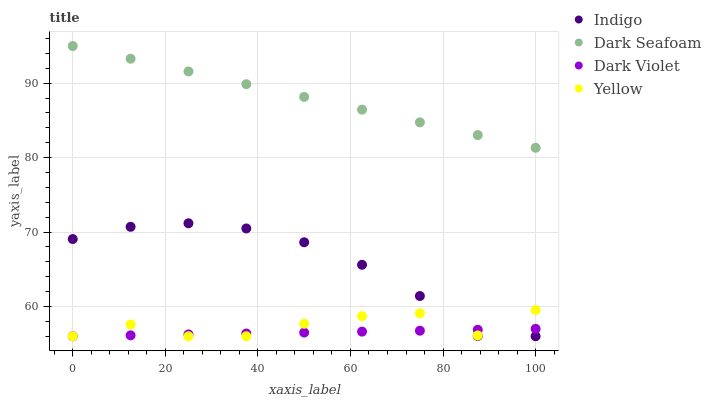Does Dark Violet have the minimum area under the curve?
Answer yes or no. Yes. Does Dark Seafoam have the maximum area under the curve?
Answer yes or no. Yes. Does Indigo have the minimum area under the curve?
Answer yes or no. No. Does Indigo have the maximum area under the curve?
Answer yes or no. No. Is Dark Seafoam the smoothest?
Answer yes or no. Yes. Is Yellow the roughest?
Answer yes or no. Yes. Is Indigo the smoothest?
Answer yes or no. No. Is Indigo the roughest?
Answer yes or no. No. Does Indigo have the lowest value?
Answer yes or no. Yes. Does Dark Seafoam have the highest value?
Answer yes or no. Yes. Does Indigo have the highest value?
Answer yes or no. No. Is Yellow less than Dark Seafoam?
Answer yes or no. Yes. Is Dark Seafoam greater than Dark Violet?
Answer yes or no. Yes. Does Yellow intersect Indigo?
Answer yes or no. Yes. Is Yellow less than Indigo?
Answer yes or no. No. Is Yellow greater than Indigo?
Answer yes or no. No. Does Yellow intersect Dark Seafoam?
Answer yes or no. No. 